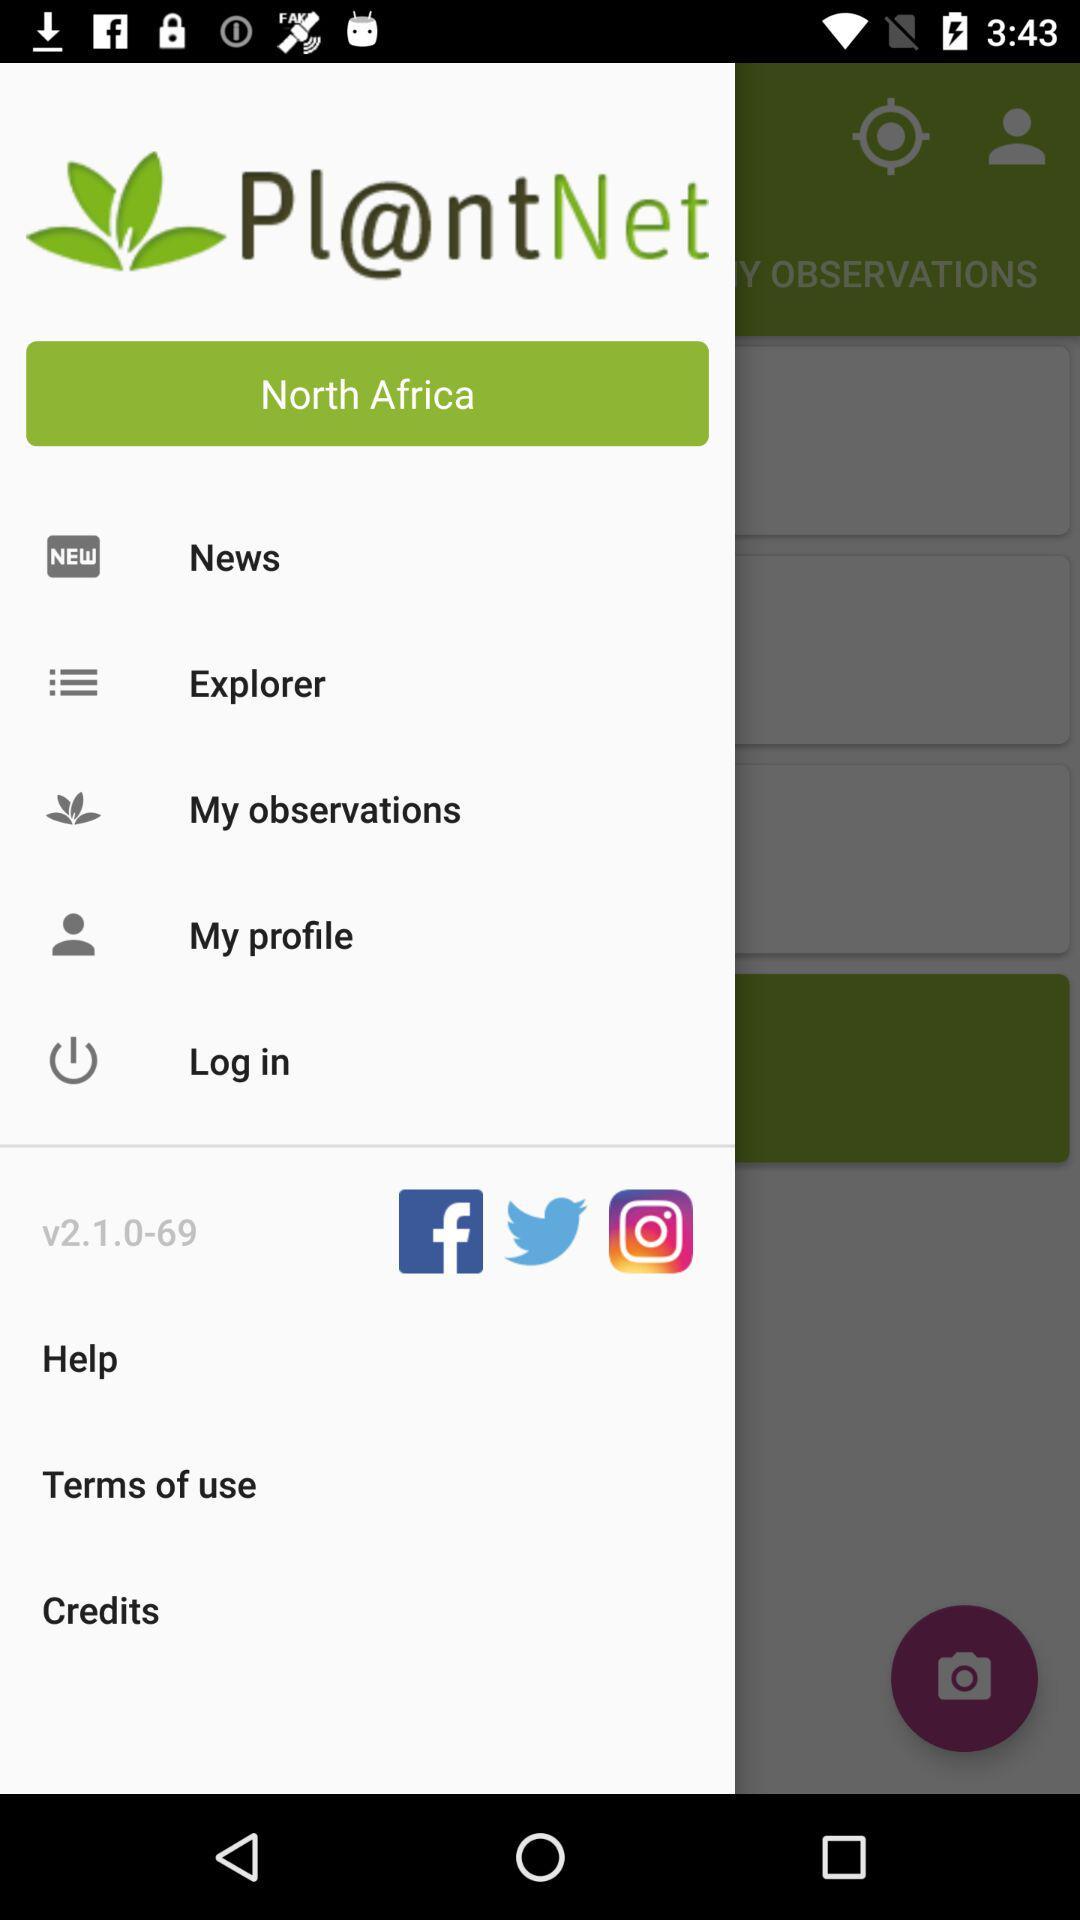Which applications can be used to share? The applications are "Facebook", "Twitter" and "Instagram". 